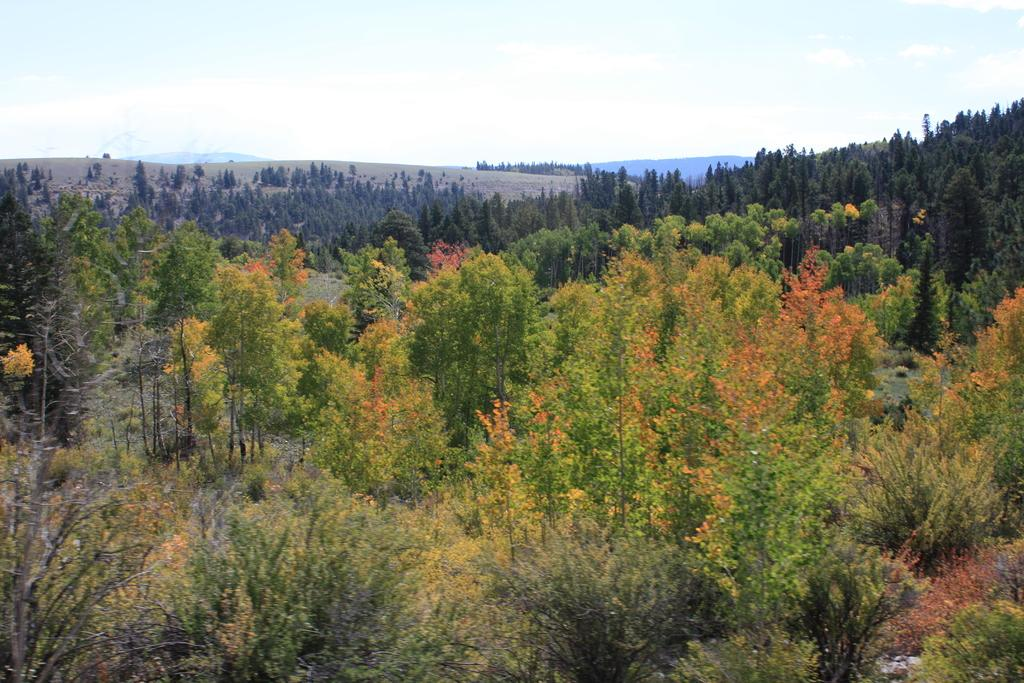What type of vegetation is present in the image? There are many trees in the image. Can you describe the background of the image? There are trees and hills visible in the background of the image, along with the sky. Where is the straw stored in the image? There is no straw present in the image. What type of game is being played in the image? There is no game being played in the image. 